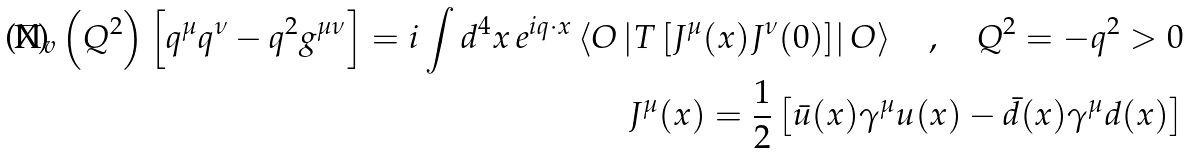Convert formula to latex. <formula><loc_0><loc_0><loc_500><loc_500>\Pi _ { v } \left ( Q ^ { 2 } \right ) \left [ q ^ { \mu } q ^ { \nu } - q ^ { 2 } g ^ { \mu \nu } \right ] = i \int d ^ { 4 } x \, e ^ { i q \cdot x } \left \langle O \left | T \left [ J ^ { \mu } ( x ) J ^ { \nu } ( 0 ) \right ] \right | O \right \rangle \quad , \quad Q ^ { 2 } = - q ^ { 2 } > 0 \\ J ^ { \mu } ( x ) = \frac { 1 } { 2 } \left [ \bar { u } ( x ) \gamma ^ { \mu } u ( x ) - \bar { d } ( x ) \gamma ^ { \mu } d ( x ) \right ]</formula> 